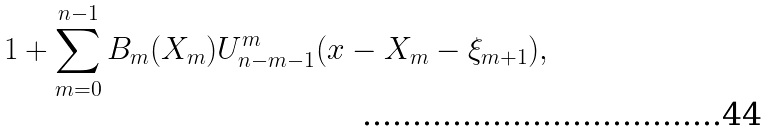<formula> <loc_0><loc_0><loc_500><loc_500>1 + \sum _ { m = 0 } ^ { n - 1 } B _ { m } ( X _ { m } ) U ^ { m } _ { n - m - 1 } ( x - X _ { m } - \xi _ { m + 1 } ) ,</formula> 